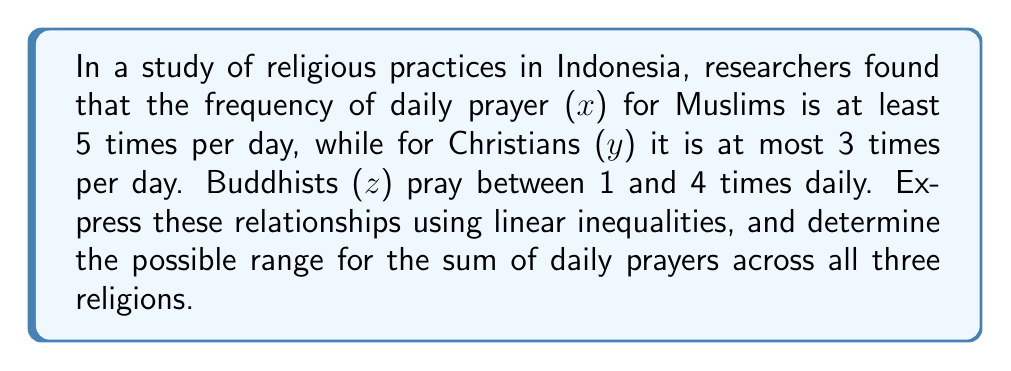Provide a solution to this math problem. Let's approach this step-by-step:

1) First, we express the given information as linear inequalities:

   For Muslims: $x \geq 5$
   For Christians: $y \leq 3$
   For Buddhists: $1 \leq z \leq 4$

2) Now, we need to find the range for the sum of daily prayers $(x + y + z)$:

3) For the minimum possible sum:
   - Muslims pray at least 5 times: $x = 5$
   - Christians pray at most 0 times (since y ≤ 3 includes 0): $y = 0$
   - Buddhists pray at least once: $z = 1$
   
   Minimum sum: $5 + 0 + 1 = 6$

4) For the maximum possible sum:
   - Muslims could pray more than 5 times, but we don't have an upper limit, so we'll use 5: $x = 5$
   - Christians pray at most 3 times: $y = 3$
   - Buddhists pray at most 4 times: $z = 4$
   
   Maximum sum: $5 + 3 + 4 = 12$

5) Therefore, the range for the sum of daily prayers can be expressed as:

   $6 \leq x + y + z \leq 12$
Answer: $6 \leq x + y + z \leq 12$ 